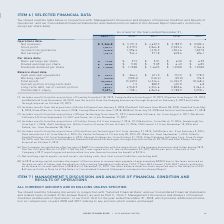According to Roper Technologies's financial document, How should we read the table in conjunction with it? “Management’s Discussion and Analysis of Financial Condition and Results of Operations” and our Consolidated Financial Statements and related notes included in this Annual Report. The document states: "ou should read the table below in conjunction with “Management’s Discussion and Analysis of Financial Condition and Results of Operations” and our Con..." Also, What does the operations data consist of? The document contains multiple relevant values: Net revenues, Gross profit, Income from operations, Net earnings. From the document: "Income from operations 1,498.4 1,396.4 1,210.2 1,054.6 1,027.9 Net earnings (6) 1,767.9 944.4 971.8 658.6 696.1 Gross profit 3,427.1 3,279.5 2,864.8 2..." Also, How much were the total assets during fiscal years 2018 and 2019, respectively? The document shows two values: 15,249.5 and 18,108.9 (in millions). From the document: "Total assets 18,108.9 15,249.5 14,316.4 14,324.9 10,168.4 Total assets 18,108.9 15,249.5 14,316.4 14,324.9 10,168.4..." Also, can you calculate: What are the average net revenues from 2015 to 2019? To answer this question, I need to perform calculations using the financial data. The calculation is: (5,366.8+5,191.2+4,607.5+3,789.9+3,582.4)/5 , which equals 4507.56 (in millions). This is based on the information: "Net revenues $ 5,366.8 $ 5,191.2 $ 4,607.5 $ 3,789.9 $ 3,582.4 Net revenues $ 5,366.8 $ 5,191.2 $ 4,607.5 $ 3,789.9 $ 3,582.4 Net revenues $ 5,366.8 $ 5,191.2 $ 4,607.5 $ 3,789.9 $ 3,582.4 evenues $ 5..." The key data points involved are: 3,582.4, 3,789.9, 4,607.5. Also, can you calculate: What is the percentage change in cash and cash equivalents in 2018 compared to 2015? To answer this question, I need to perform calculations using the financial data. The calculation is: (364.4-778.5)/778.5 , which equals -53.19 (percentage). This is based on the information: "Cash and cash equivalents $ 709.7 $ 364.4 $ 671.3 $ 757.2 $ 778.5 ash equivalents $ 709.7 $ 364.4 $ 671.3 $ 757.2 $ 778.5..." The key data points involved are: 364.4, 778.5. Also, can you calculate: What is the cost of goods sold (COGS) in 2017? Based on the calculation: 4,607.5 - 2,864.8 , the result is 1742.7 (in millions). This is based on the information: "Gross profit 3,427.1 3,279.5 2,864.8 2,332.4 2,164.6 Net revenues $ 5,366.8 $ 5,191.2 $ 4,607.5 $ 3,789.9 $ 3,582.4..." The key data points involved are: 2,864.8, 4,607.5. 